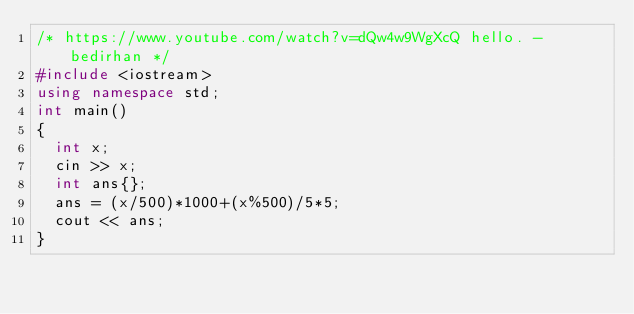Convert code to text. <code><loc_0><loc_0><loc_500><loc_500><_C++_>/* https://www.youtube.com/watch?v=dQw4w9WgXcQ hello. -bedirhan */
#include <iostream>
using namespace std;
int main()
{
  int x;
  cin >> x;
  int ans{};
  ans = (x/500)*1000+(x%500)/5*5;
  cout << ans;
}
</code> 